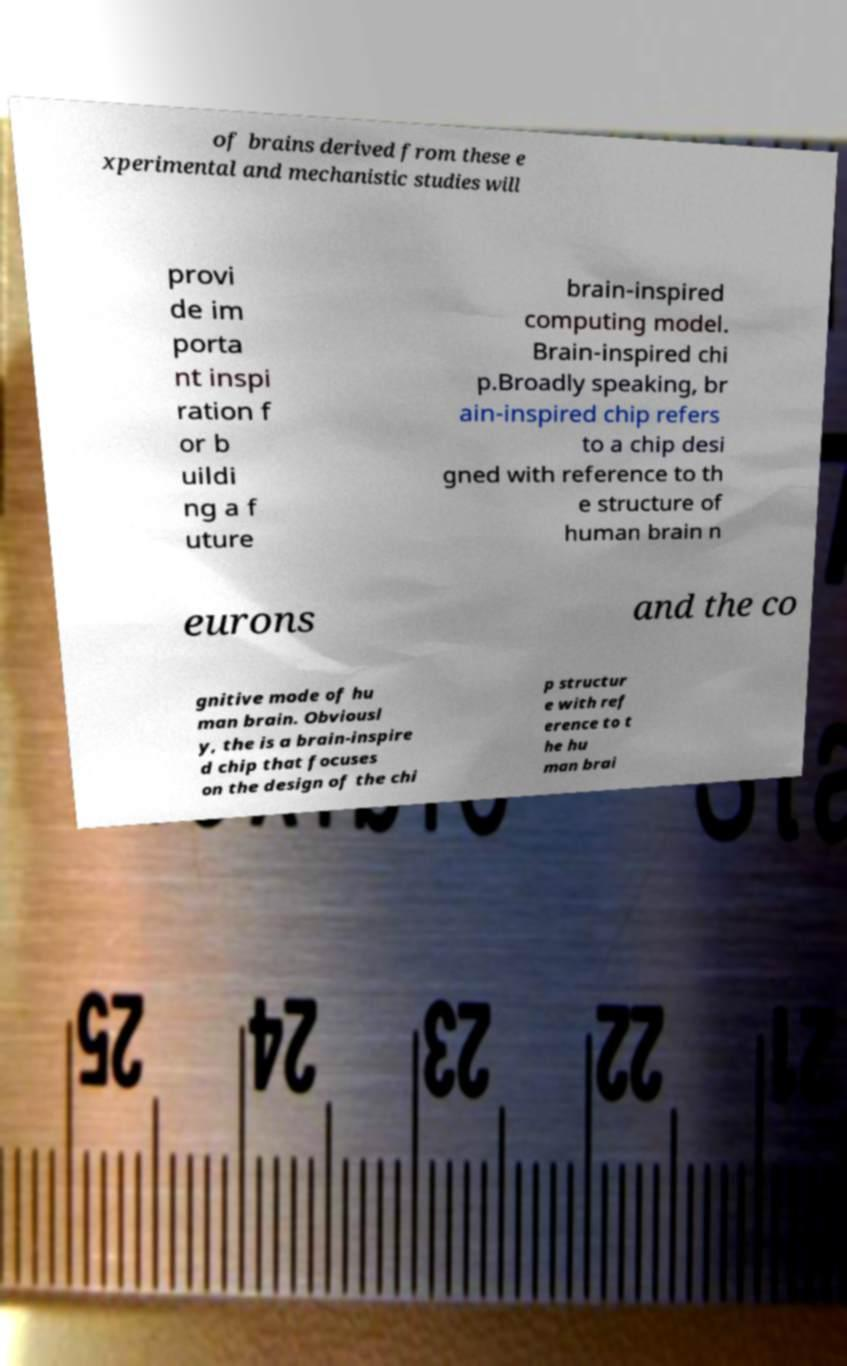There's text embedded in this image that I need extracted. Can you transcribe it verbatim? of brains derived from these e xperimental and mechanistic studies will provi de im porta nt inspi ration f or b uildi ng a f uture brain-inspired computing model. Brain-inspired chi p.Broadly speaking, br ain-inspired chip refers to a chip desi gned with reference to th e structure of human brain n eurons and the co gnitive mode of hu man brain. Obviousl y, the is a brain-inspire d chip that focuses on the design of the chi p structur e with ref erence to t he hu man brai 